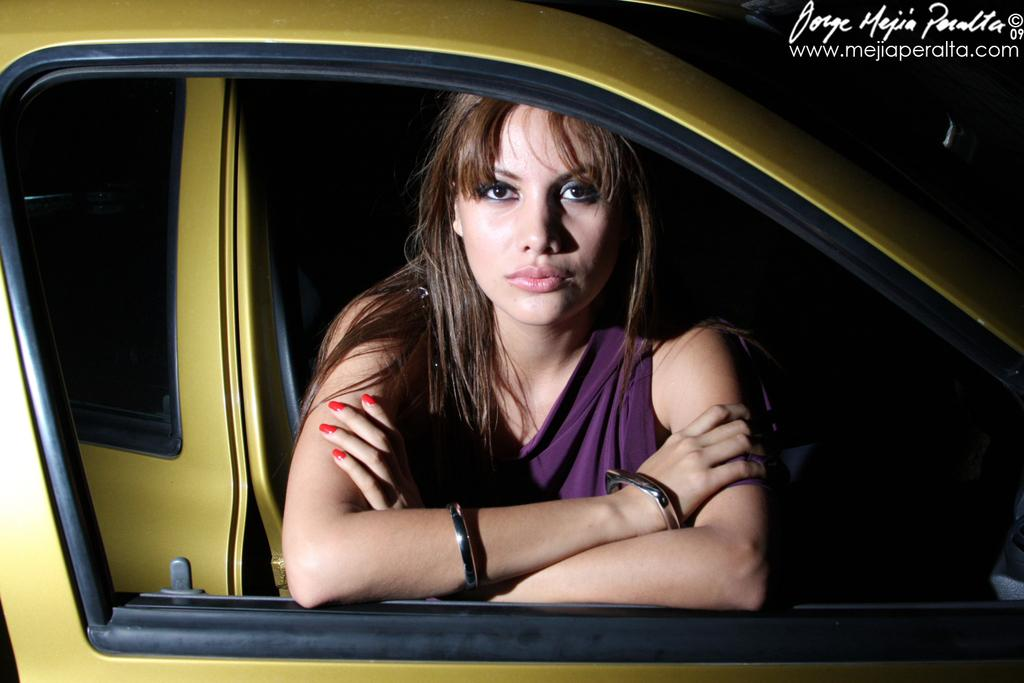Who is present in the image? There is a woman in the image. What is the woman doing or where is she located? The woman is in a vehicle. What type of pear is the woman holding in the image? There is no pear present in the image. 